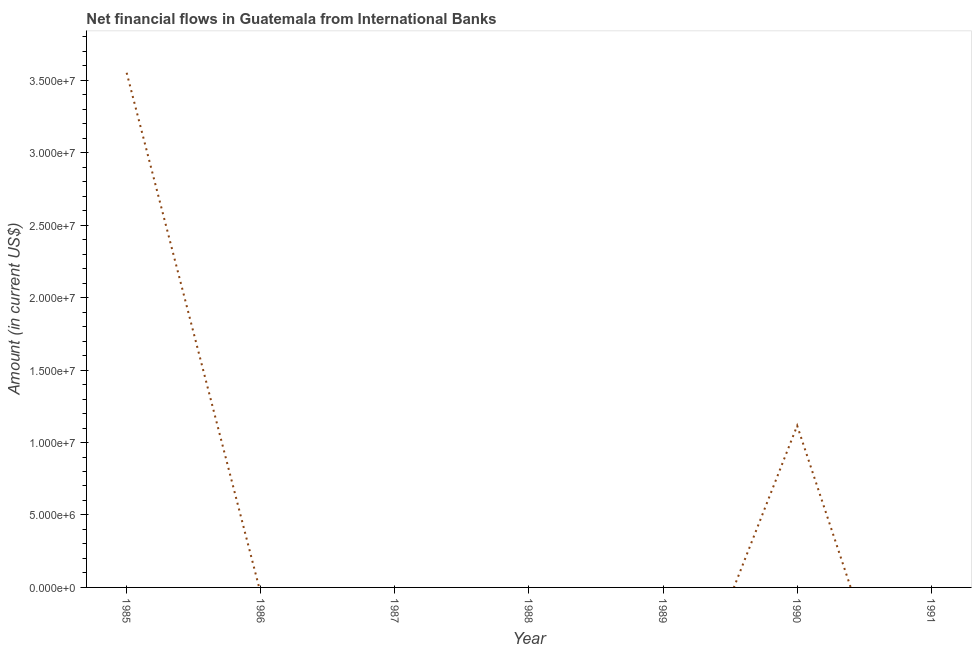Across all years, what is the maximum net financial flows from ibrd?
Offer a very short reply. 3.55e+07. What is the sum of the net financial flows from ibrd?
Make the answer very short. 4.67e+07. What is the average net financial flows from ibrd per year?
Make the answer very short. 6.67e+06. What is the median net financial flows from ibrd?
Make the answer very short. 0. What is the ratio of the net financial flows from ibrd in 1985 to that in 1990?
Ensure brevity in your answer.  3.18. What is the difference between the highest and the lowest net financial flows from ibrd?
Your answer should be compact. 3.55e+07. Does the net financial flows from ibrd monotonically increase over the years?
Your answer should be compact. No. How many lines are there?
Provide a succinct answer. 1. How many years are there in the graph?
Make the answer very short. 7. Does the graph contain grids?
Provide a succinct answer. No. What is the title of the graph?
Offer a very short reply. Net financial flows in Guatemala from International Banks. What is the label or title of the X-axis?
Provide a short and direct response. Year. What is the label or title of the Y-axis?
Offer a very short reply. Amount (in current US$). What is the Amount (in current US$) of 1985?
Keep it short and to the point. 3.55e+07. What is the Amount (in current US$) of 1987?
Your answer should be compact. 0. What is the Amount (in current US$) in 1989?
Provide a short and direct response. 0. What is the Amount (in current US$) in 1990?
Your answer should be very brief. 1.12e+07. What is the difference between the Amount (in current US$) in 1985 and 1990?
Make the answer very short. 2.44e+07. What is the ratio of the Amount (in current US$) in 1985 to that in 1990?
Provide a succinct answer. 3.18. 